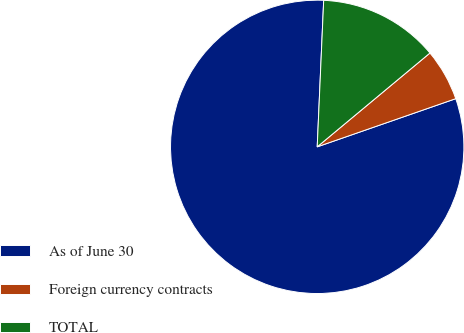Convert chart. <chart><loc_0><loc_0><loc_500><loc_500><pie_chart><fcel>As of June 30<fcel>Foreign currency contracts<fcel>TOTAL<nl><fcel>81.03%<fcel>5.72%<fcel>13.25%<nl></chart> 